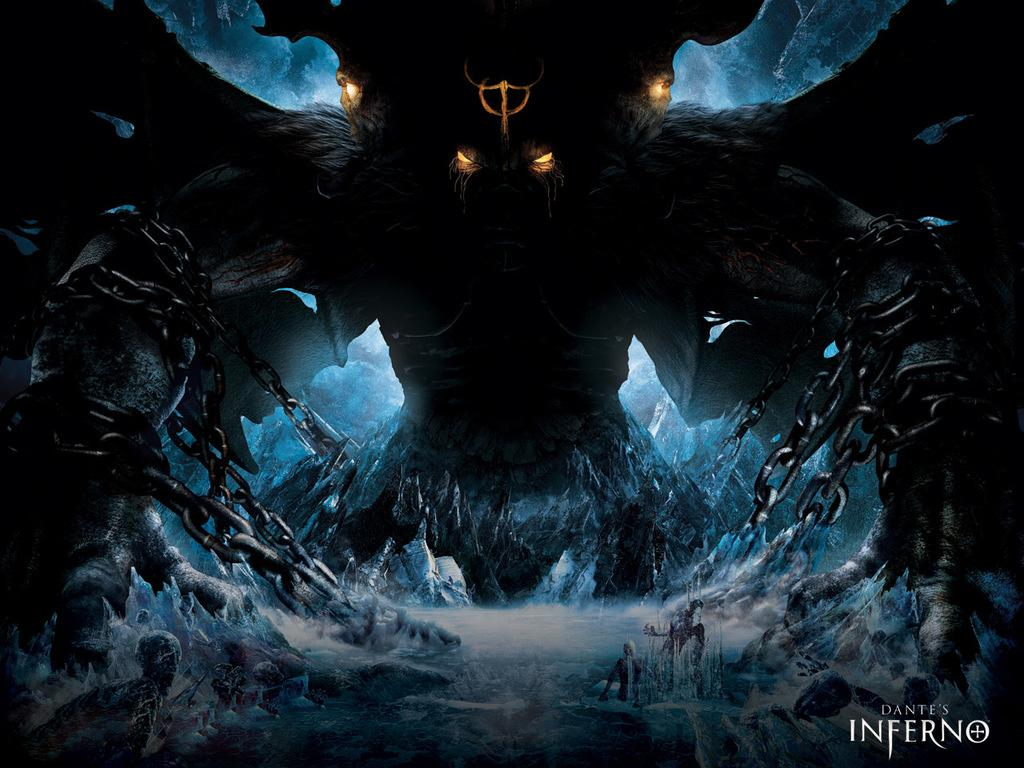What is the main subject of the image? There is a monster in the image. How is the monster being restrained? The monster is tied with chains. What type of terrain is visible in the image? There are ice hills in the image. Are there any other living beings in the image besides the monster? Yes, there are people in the image. What is the cause of the sponge's sudden disappearance in the image? There is no sponge present in the image, so it cannot be determined what caused its disappearance. 